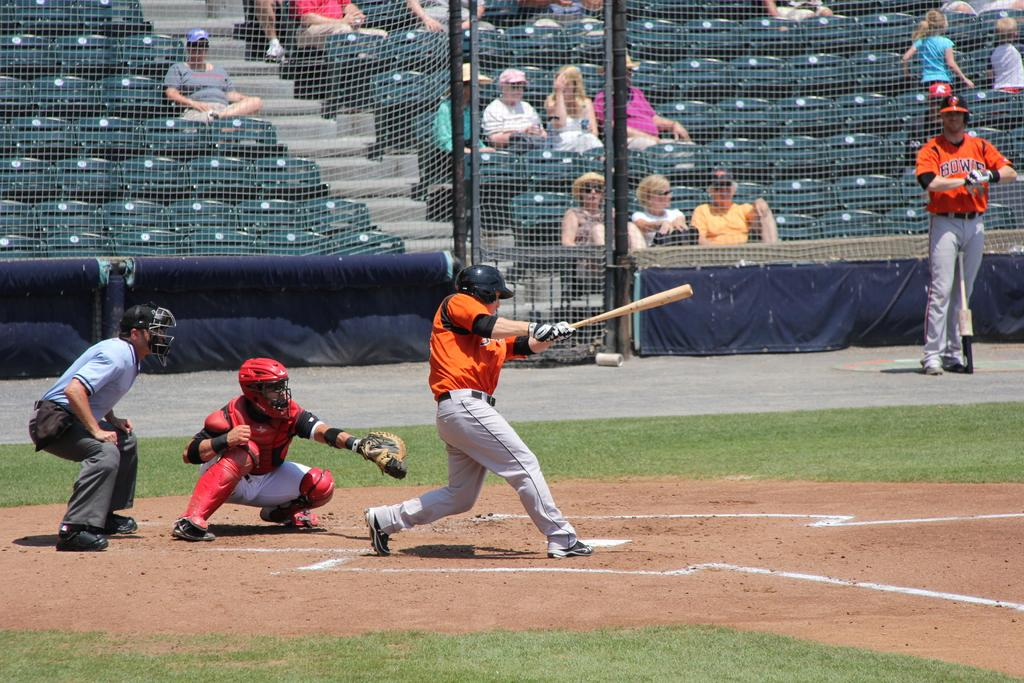Provide a one-sentence caption for the provided image. A player for the baseball team Bowie in an orange and gray uniform swings at the ball. 